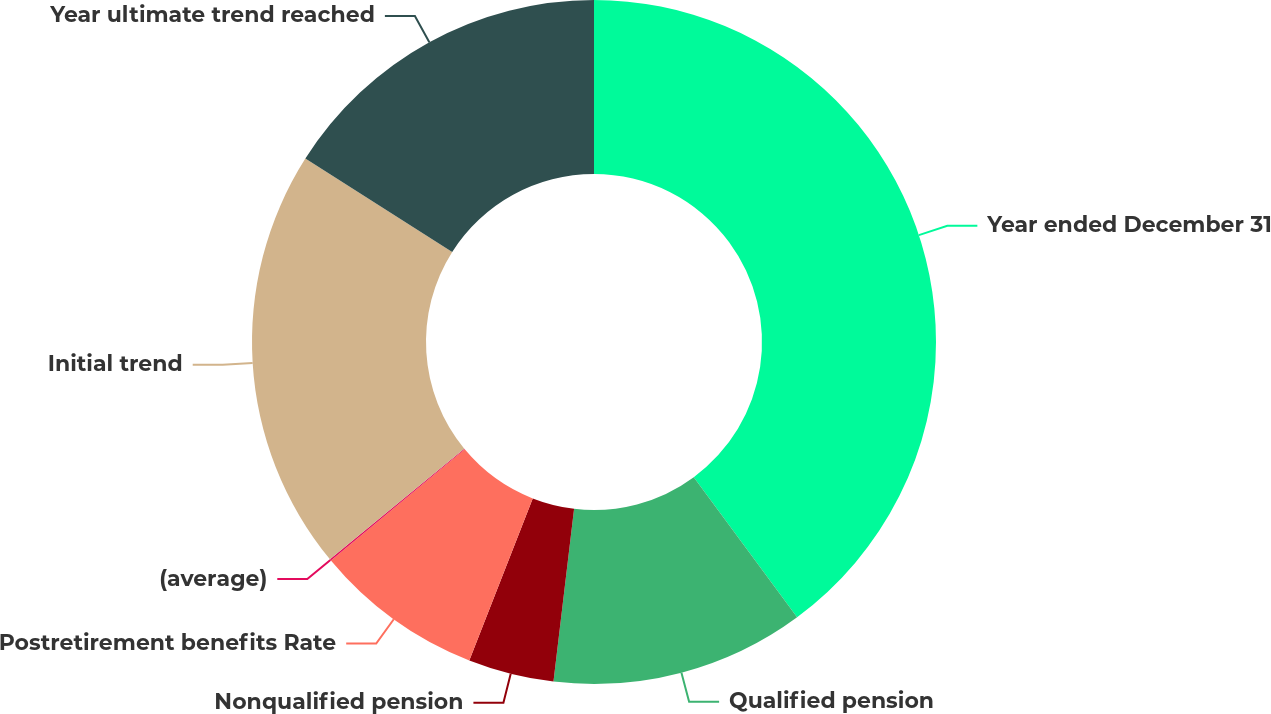<chart> <loc_0><loc_0><loc_500><loc_500><pie_chart><fcel>Year ended December 31<fcel>Qualified pension<fcel>Nonqualified pension<fcel>Postretirement benefits Rate<fcel>(average)<fcel>Initial trend<fcel>Year ultimate trend reached<nl><fcel>39.88%<fcel>12.01%<fcel>4.05%<fcel>8.03%<fcel>0.07%<fcel>19.97%<fcel>15.99%<nl></chart> 